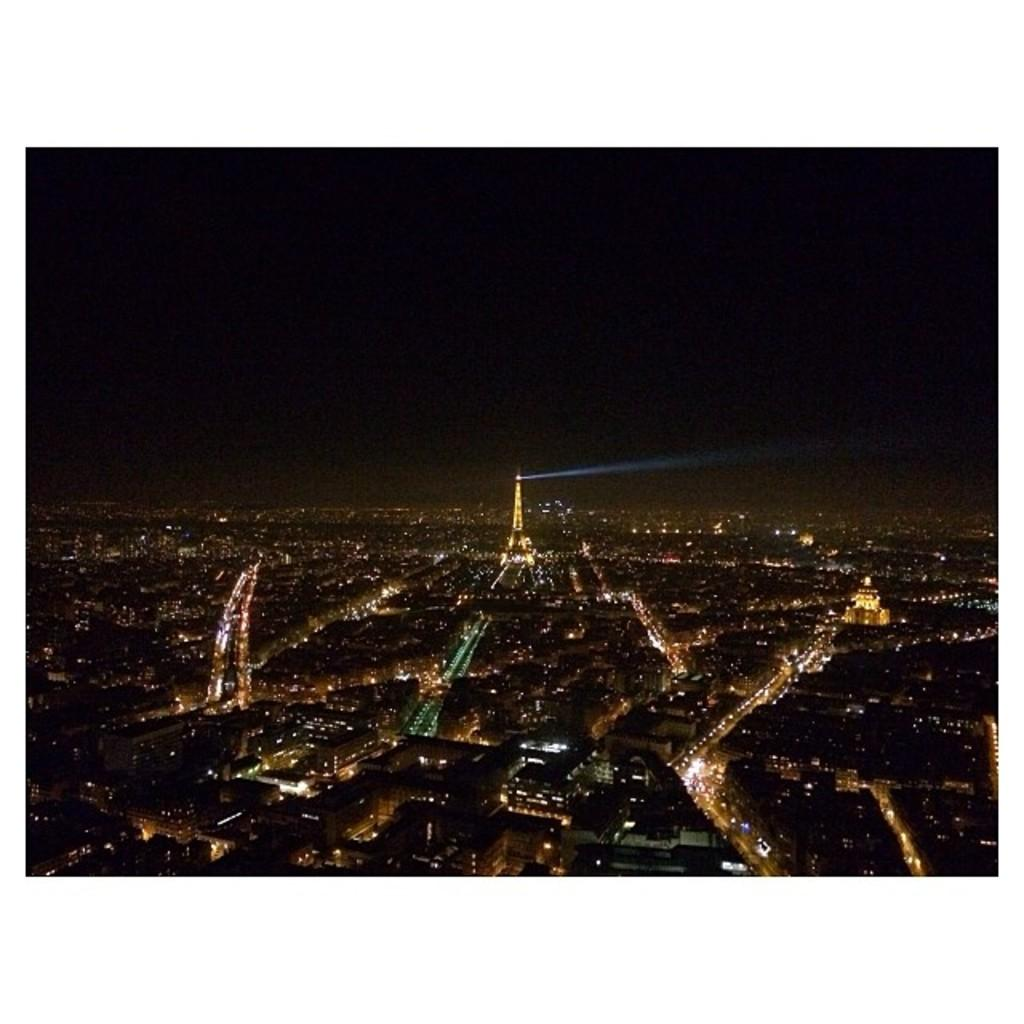What type of structures are present in the image? There are buildings in the image. What can be observed about the buildings in the image? The buildings have lights on them. What type of sign can be seen on the boat in the image? There is no boat present in the image, so it is not possible to answer that question. 